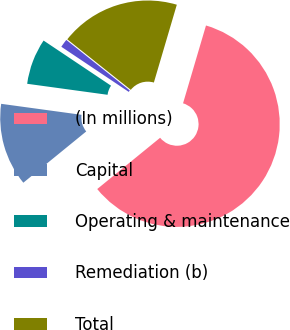Convert chart to OTSL. <chart><loc_0><loc_0><loc_500><loc_500><pie_chart><fcel>(In millions)<fcel>Capital<fcel>Operating & maintenance<fcel>Remediation (b)<fcel>Total<nl><fcel>59.55%<fcel>13.05%<fcel>7.22%<fcel>1.31%<fcel>18.87%<nl></chart> 